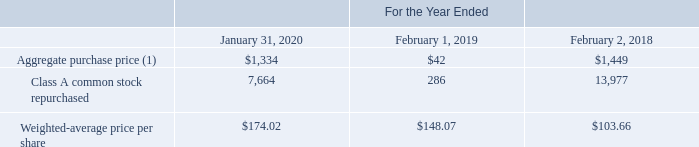VMware Stock Repurchases
VMware purchases stock from time to time in open market transactions, subject to market conditions. The timing of any repurchases and the actual number of shares repurchased will depend on a variety of factors, including VMware’s stock price, cash requirements for operations and business combinations, corporate, legal and regulatory requirements and other market and economic conditions. VMware is not obligated to purchase any shares under its stock repurchase programs. Purchases can be discontinued at any time VMware believes additional purchases are not warranted. From time to time, VMware also purchases stock in private transactions, such as those with Dell. All shares repurchased under VMware’s stock repurchase programs are retired.
The following table summarizes stock repurchase activity, including shares purchased from Dell, during the periods presented (aggregate purchase price in millions, shares in thousands):
(1) The aggregate purchase price of repurchased shares is classified as a reduction to additional paid-in capital until the balance is reduced to zero and the excess is recorded as a reduction to retained earnings.
What was the aggregate purchase price classified as? A reduction to additional paid-in capital until the balance is reduced to zero and the excess is recorded as a reduction to retained earnings. What was the Class A common stock repurchased in 2019?
Answer scale should be: thousand. 286. What was the Weighted-average price per share in 2018? 103.66. How many years did Class A common stock repurchased exceed $10,000 million? 2018
Answer: 1. What was the change in Aggregate purchase price between 2018 and 2019?
Answer scale should be: million. 42-1,449
Answer: -1407. What was the percentage change in weighted-average price per share between 2019 and 2020?
Answer scale should be: percent. (174.02-148.07)/148.07
Answer: 17.53. 